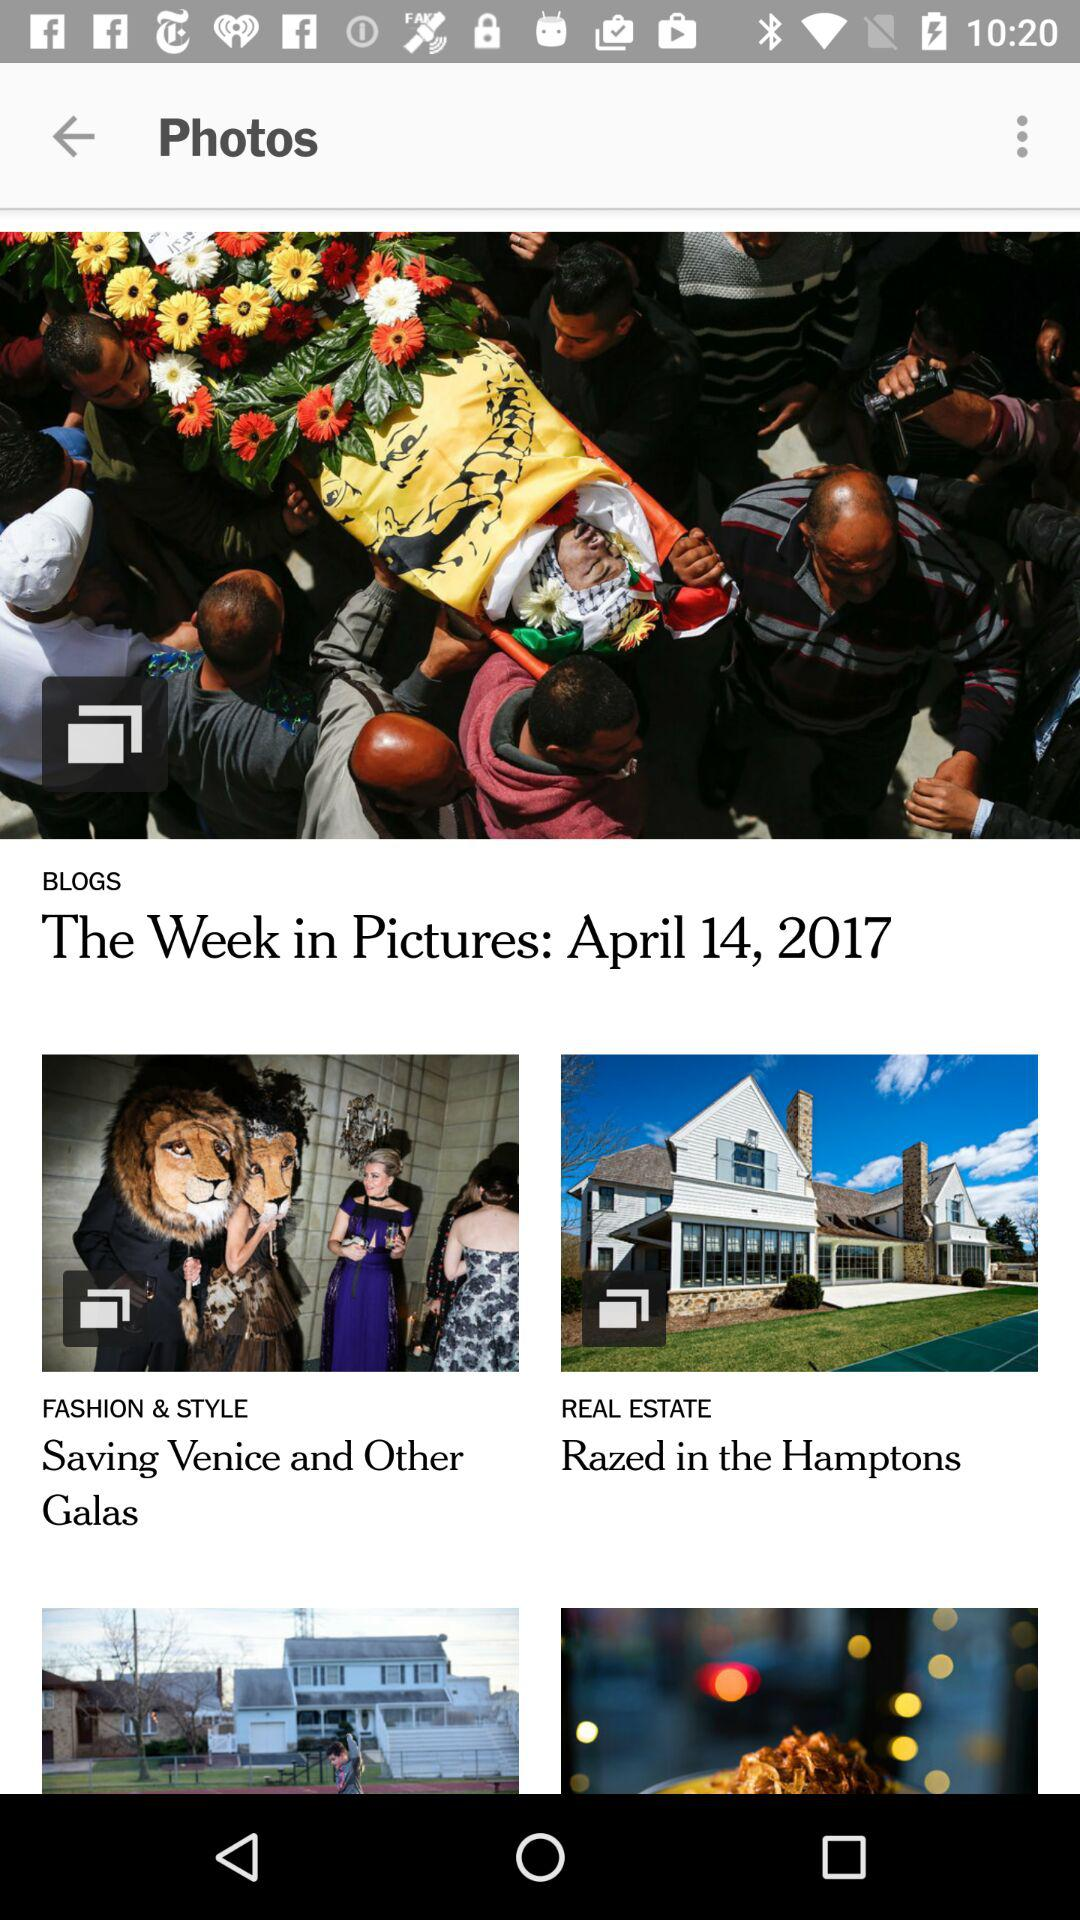What is the name of the blog that falls under "FASHION & STYLE"? The name of the blog is "Saving Venice and Other Galas". 